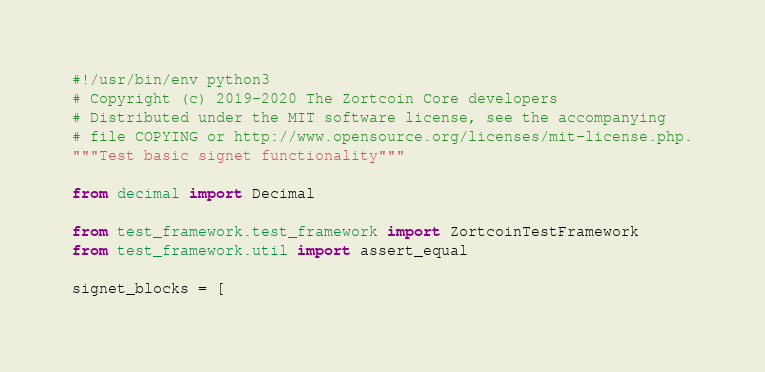<code> <loc_0><loc_0><loc_500><loc_500><_Python_>#!/usr/bin/env python3
# Copyright (c) 2019-2020 The Zortcoin Core developers
# Distributed under the MIT software license, see the accompanying
# file COPYING or http://www.opensource.org/licenses/mit-license.php.
"""Test basic signet functionality"""

from decimal import Decimal

from test_framework.test_framework import ZortcoinTestFramework
from test_framework.util import assert_equal

signet_blocks = [</code> 